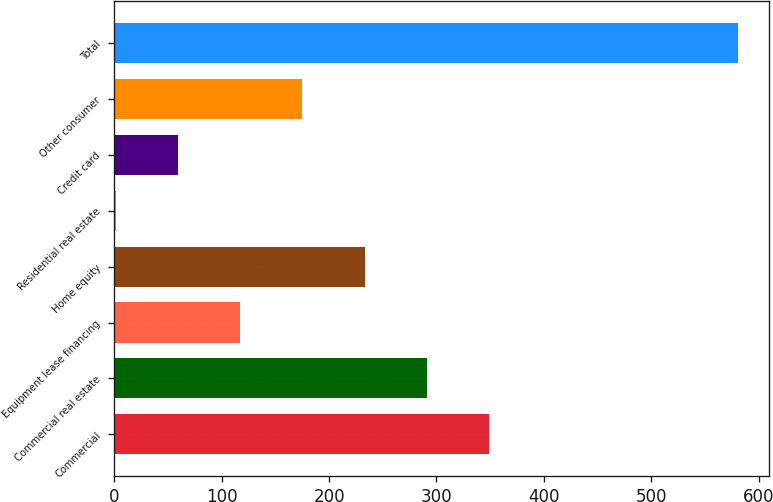Convert chart to OTSL. <chart><loc_0><loc_0><loc_500><loc_500><bar_chart><fcel>Commercial<fcel>Commercial real estate<fcel>Equipment lease financing<fcel>Home equity<fcel>Residential real estate<fcel>Credit card<fcel>Other consumer<fcel>Total<nl><fcel>349<fcel>291<fcel>117<fcel>233<fcel>1<fcel>59<fcel>175<fcel>581<nl></chart> 